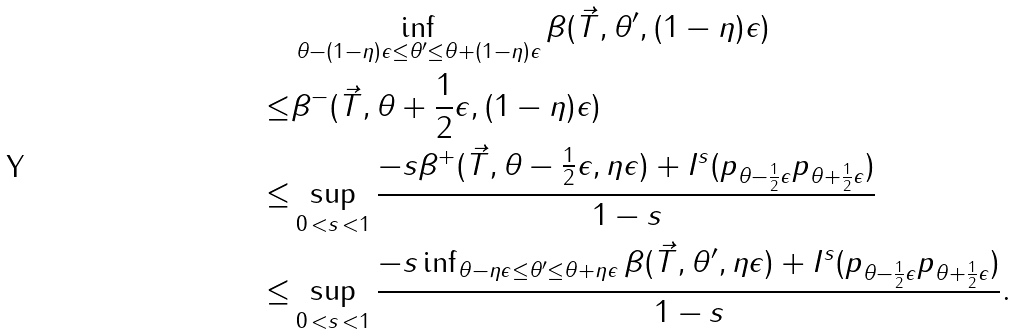<formula> <loc_0><loc_0><loc_500><loc_500>& \inf _ { \theta - ( 1 - \eta ) \epsilon \leq \theta ^ { \prime } \leq \theta + ( 1 - \eta ) \epsilon } \beta ( \vec { T } , \theta ^ { \prime } , ( 1 - \eta ) \epsilon ) \\ \leq & \beta ^ { - } ( \vec { T } , \theta + \frac { 1 } { 2 } \epsilon , ( 1 - \eta ) \epsilon ) \\ \leq & \sup _ { 0 \, < s \, < 1 } \frac { - s \beta ^ { + } ( \vec { T } , \theta - \frac { 1 } { 2 } \epsilon , \eta \epsilon ) + I ^ { s } ( p _ { \theta - \frac { 1 } { 2 } \epsilon } \| p _ { \theta + \frac { 1 } { 2 } \epsilon } ) } { 1 - s } \\ \leq & \sup _ { 0 \, < s \, < 1 } \frac { - s \inf _ { \theta - \eta \epsilon \leq \theta ^ { \prime } \leq \theta + \eta \epsilon } \beta ( \vec { T } , \theta ^ { \prime } , \eta \epsilon ) + I ^ { s } ( p _ { \theta - \frac { 1 } { 2 } \epsilon } \| p _ { \theta + \frac { 1 } { 2 } \epsilon } ) } { 1 - s } .</formula> 